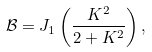<formula> <loc_0><loc_0><loc_500><loc_500>\mathcal { B } = J _ { 1 } \left ( \frac { K ^ { 2 } } { 2 + K ^ { 2 } } \right ) ,</formula> 